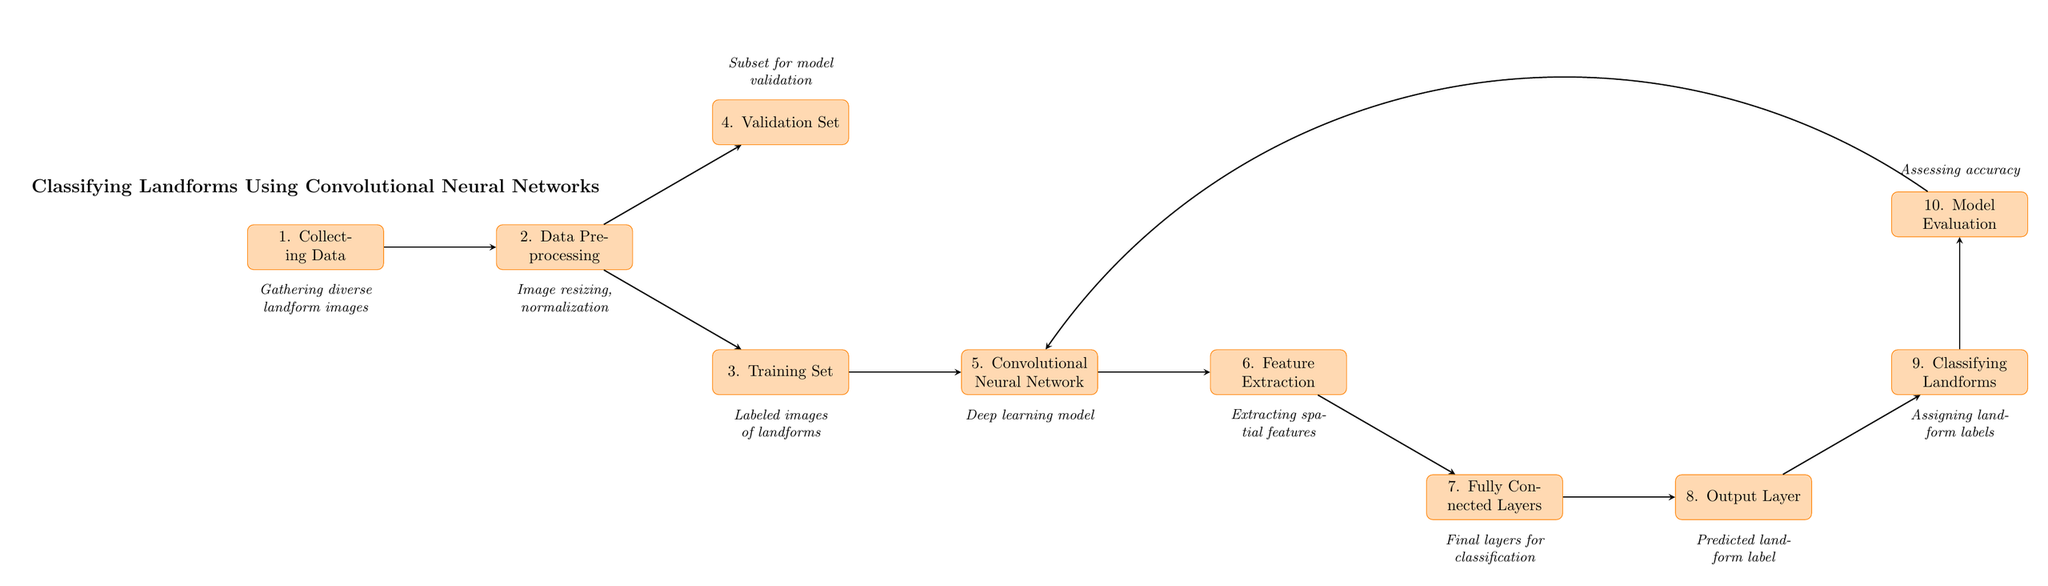What is the first step in the process? The diagram indicates that the first step in the process is "Collecting Data." This is explicitly labeled as the first node in the flowchart.
Answer: Collecting Data How many main process nodes are there in total? By counting the rectangles in the diagram, we find there are ten main process nodes represented.
Answer: 10 What is the output of the "Output Layer"? The "Output Layer" node specifies that it produces "Predicted landform label." This is clearly stated in the process flow.
Answer: Predicted landform label Which process follows "Training Set"? The diagram shows that after the "Training Set," the next process is "Convolutional Neural Network," indicating the sequence of operations.
Answer: Convolutional Neural Network What is the purpose of the "Model Evaluation"? The "Model Evaluation" node describes its purpose as "Assessing accuracy," which clarifies the goal of this step in the process.
Answer: Assessing accuracy What two sets are created from the "Data Preprocessing"? From "Data Preprocessing," two sets are indicated: "Training Set" and "Validation Set," showing that this step produces these two outputs for model training and validation.
Answer: Training Set, Validation Set What is extracted in the "Feature Extraction" process? The "Feature Extraction" step involves "Extracting spatial features," a crucial operation for preparing data for the model’s final layers.
Answer: Extracting spatial features Which stage does the evaluation feed back into? The "Model Evaluation" process is shown to feed back into the "Convolutional Neural Network," suggesting an iterative process to refine the model based on its performance.
Answer: Convolutional Neural Network What describes the role of "Fully Connected Layers"? The diagram states that "Fully Connected Layers" are responsible for "Final layers for classification," which emphasizes their function in the classification process.
Answer: Final layers for classification 